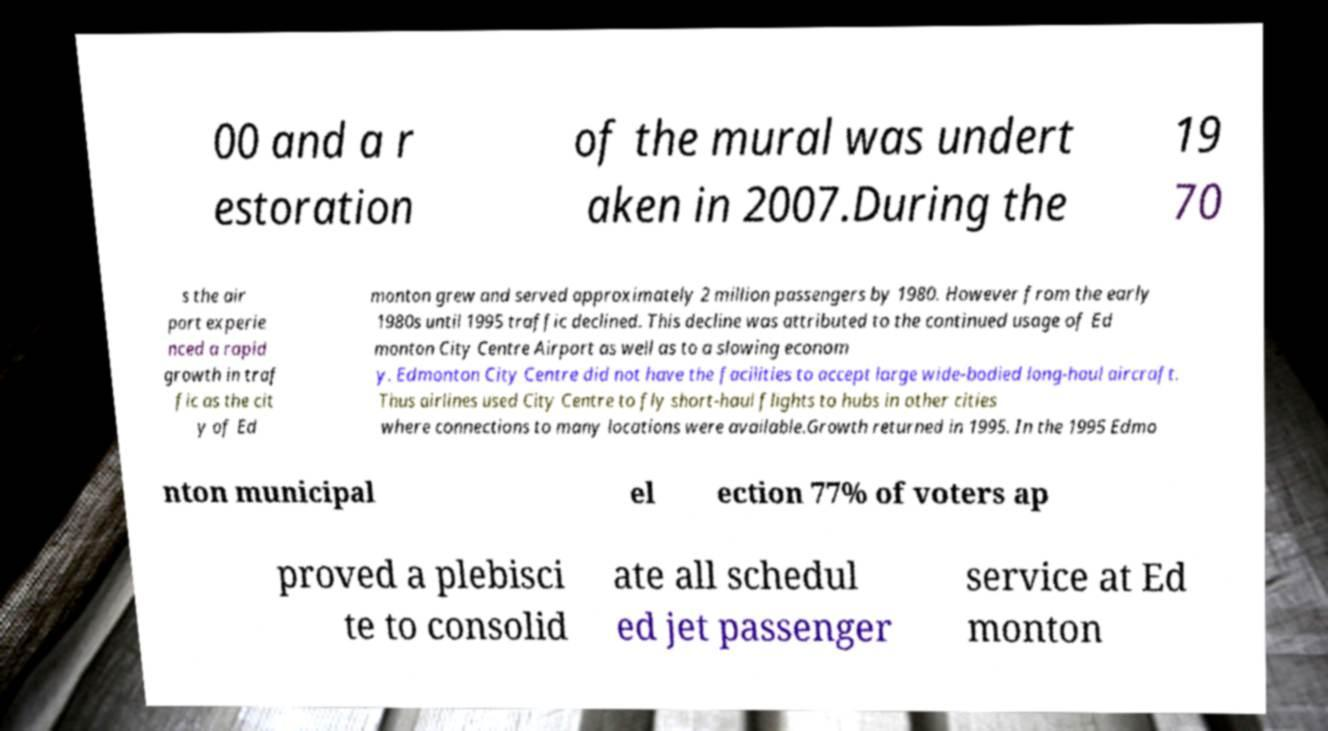Could you assist in decoding the text presented in this image and type it out clearly? 00 and a r estoration of the mural was undert aken in 2007.During the 19 70 s the air port experie nced a rapid growth in traf fic as the cit y of Ed monton grew and served approximately 2 million passengers by 1980. However from the early 1980s until 1995 traffic declined. This decline was attributed to the continued usage of Ed monton City Centre Airport as well as to a slowing econom y. Edmonton City Centre did not have the facilities to accept large wide-bodied long-haul aircraft. Thus airlines used City Centre to fly short-haul flights to hubs in other cities where connections to many locations were available.Growth returned in 1995. In the 1995 Edmo nton municipal el ection 77% of voters ap proved a plebisci te to consolid ate all schedul ed jet passenger service at Ed monton 